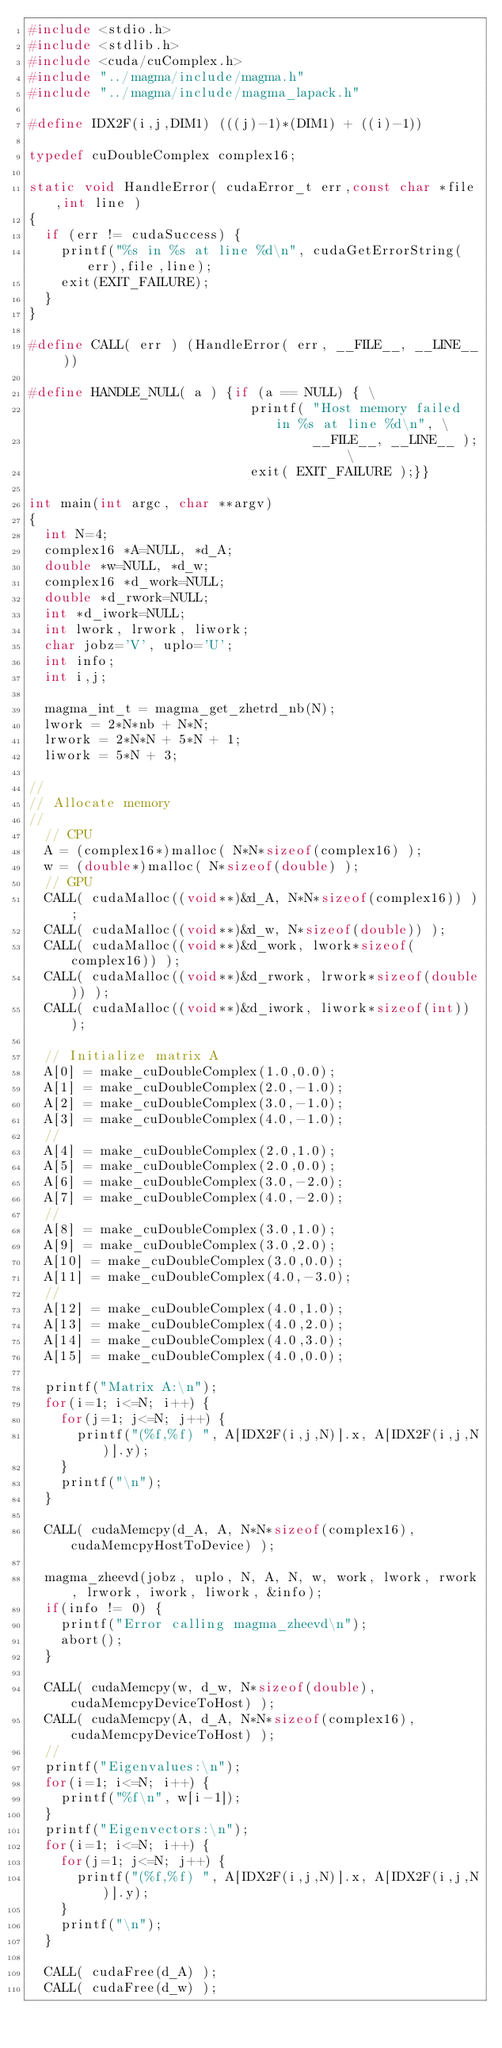Convert code to text. <code><loc_0><loc_0><loc_500><loc_500><_C++_>#include <stdio.h>
#include <stdlib.h>
#include <cuda/cuComplex.h>
#include "../magma/include/magma.h"
#include "../magma/include/magma_lapack.h"

#define IDX2F(i,j,DIM1) (((j)-1)*(DIM1) + ((i)-1))

typedef cuDoubleComplex complex16;

static void HandleError( cudaError_t err,const char *file,int line )
{
  if (err != cudaSuccess) {
    printf("%s in %s at line %d\n", cudaGetErrorString(err),file,line);
    exit(EXIT_FAILURE);
  }
}

#define CALL( err ) (HandleError( err, __FILE__, __LINE__ ))

#define HANDLE_NULL( a ) {if (a == NULL) { \
                            printf( "Host memory failed in %s at line %d\n", \
                                    __FILE__, __LINE__ ); \
                            exit( EXIT_FAILURE );}}

int main(int argc, char **argv)
{
  int N=4;
  complex16 *A=NULL, *d_A;
  double *w=NULL, *d_w;
  complex16 *d_work=NULL;
  double *d_rwork=NULL;
  int *d_iwork=NULL;
  int lwork, lrwork, liwork;
  char jobz='V', uplo='U';
  int info;
  int i,j;

  magma_int_t = magma_get_zhetrd_nb(N);
  lwork = 2*N*nb + N*N;
  lrwork = 2*N*N + 5*N + 1;
  liwork = 5*N + 3;

//
// Allocate memory
//
  // CPU
  A = (complex16*)malloc( N*N*sizeof(complex16) );
  w = (double*)malloc( N*sizeof(double) );
  // GPU
  CALL( cudaMalloc((void**)&d_A, N*N*sizeof(complex16)) );
  CALL( cudaMalloc((void**)&d_w, N*sizeof(double)) );
  CALL( cudaMalloc((void**)&d_work, lwork*sizeof(complex16)) );
  CALL( cudaMalloc((void**)&d_rwork, lrwork*sizeof(double)) );
  CALL( cudaMalloc((void**)&d_iwork, liwork*sizeof(int)) );

  // Initialize matrix A
  A[0] = make_cuDoubleComplex(1.0,0.0);
  A[1] = make_cuDoubleComplex(2.0,-1.0);
  A[2] = make_cuDoubleComplex(3.0,-1.0);
  A[3] = make_cuDoubleComplex(4.0,-1.0);
  //
  A[4] = make_cuDoubleComplex(2.0,1.0);
  A[5] = make_cuDoubleComplex(2.0,0.0);
  A[6] = make_cuDoubleComplex(3.0,-2.0);
  A[7] = make_cuDoubleComplex(4.0,-2.0);
  //
  A[8] = make_cuDoubleComplex(3.0,1.0);
  A[9] = make_cuDoubleComplex(3.0,2.0);
  A[10] = make_cuDoubleComplex(3.0,0.0);
  A[11] = make_cuDoubleComplex(4.0,-3.0);
  //
  A[12] = make_cuDoubleComplex(4.0,1.0);
  A[13] = make_cuDoubleComplex(4.0,2.0);
  A[14] = make_cuDoubleComplex(4.0,3.0);
  A[15] = make_cuDoubleComplex(4.0,0.0);

  printf("Matrix A:\n");
  for(i=1; i<=N; i++) {
    for(j=1; j<=N; j++) {
      printf("(%f,%f) ", A[IDX2F(i,j,N)].x, A[IDX2F(i,j,N)].y);
    }
    printf("\n");
  }

  CALL( cudaMemcpy(d_A, A, N*N*sizeof(complex16), cudaMemcpyHostToDevice) );

  magma_zheevd(jobz, uplo, N, A, N, w, work, lwork, rwork, lrwork, iwork, liwork, &info);
  if(info != 0) {
    printf("Error calling magma_zheevd\n");
    abort();
  }

  CALL( cudaMemcpy(w, d_w, N*sizeof(double), cudaMemcpyDeviceToHost) );
  CALL( cudaMemcpy(A, d_A, N*N*sizeof(complex16), cudaMemcpyDeviceToHost) );
  //
  printf("Eigenvalues:\n");
  for(i=1; i<=N; i++) {
    printf("%f\n", w[i-1]);
  }
  printf("Eigenvectors:\n");
  for(i=1; i<=N; i++) {
    for(j=1; j<=N; j++) {
      printf("(%f,%f) ", A[IDX2F(i,j,N)].x, A[IDX2F(i,j,N)].y);
    }
    printf("\n");
  }

  CALL( cudaFree(d_A) );
  CALL( cudaFree(d_w) );</code> 